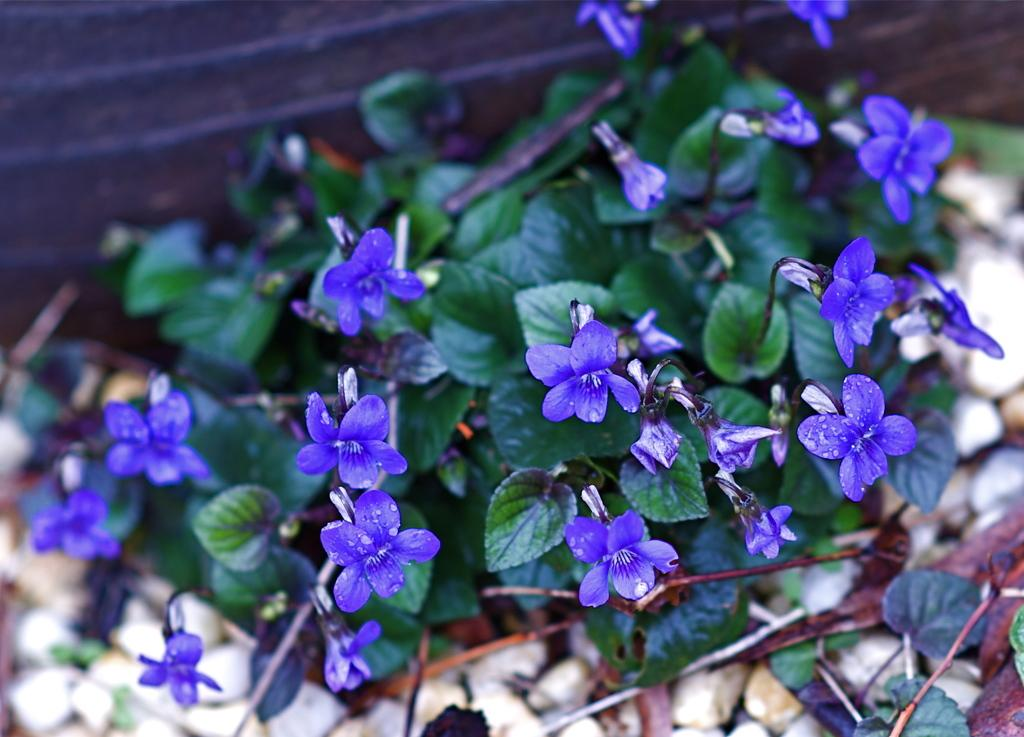What is the main subject of the image? The main subject of the image is plants. Where are the plants located in the image? The plants are in the center of the image. What additional feature can be observed on the plants? The plants have flowers on them. How does the crowd react to the desire to smash the plants in the image? There is no crowd present in the image, and the plants are not being smashed. 